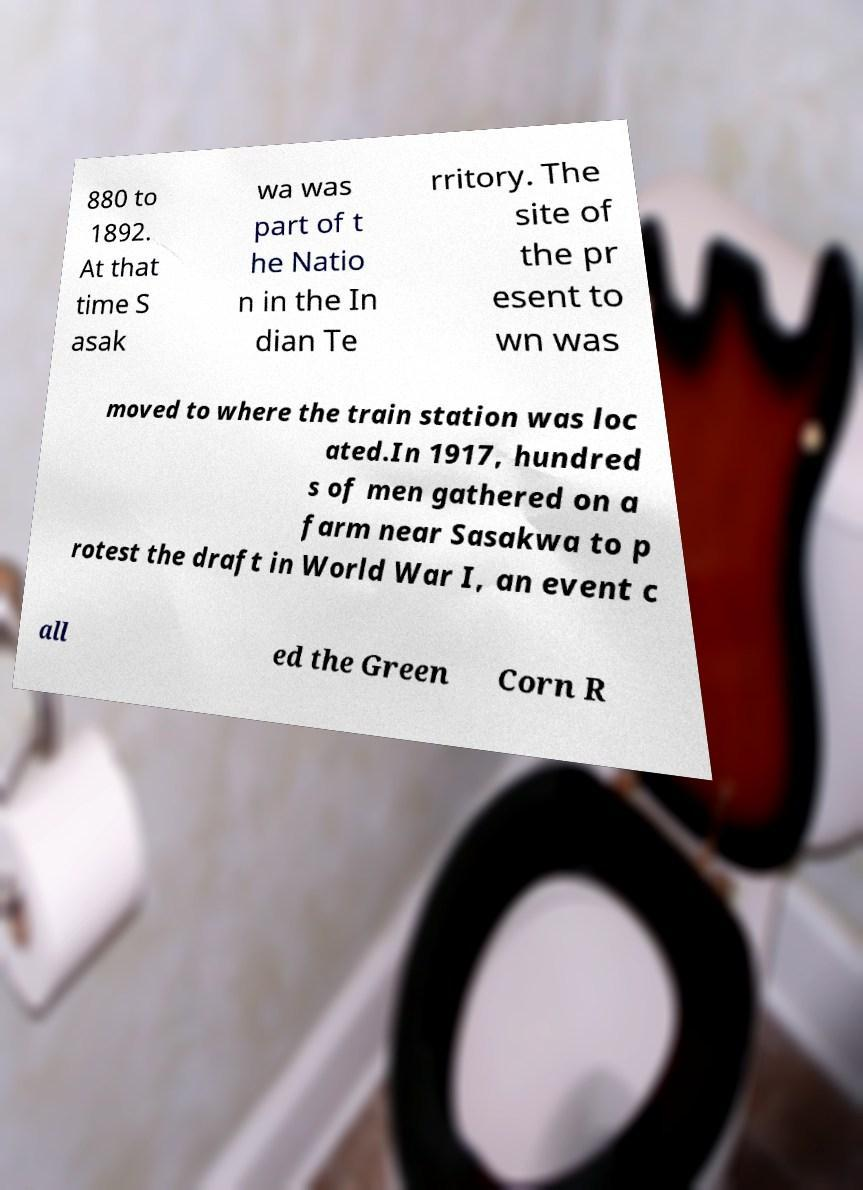What messages or text are displayed in this image? I need them in a readable, typed format. 880 to 1892. At that time S asak wa was part of t he Natio n in the In dian Te rritory. The site of the pr esent to wn was moved to where the train station was loc ated.In 1917, hundred s of men gathered on a farm near Sasakwa to p rotest the draft in World War I, an event c all ed the Green Corn R 